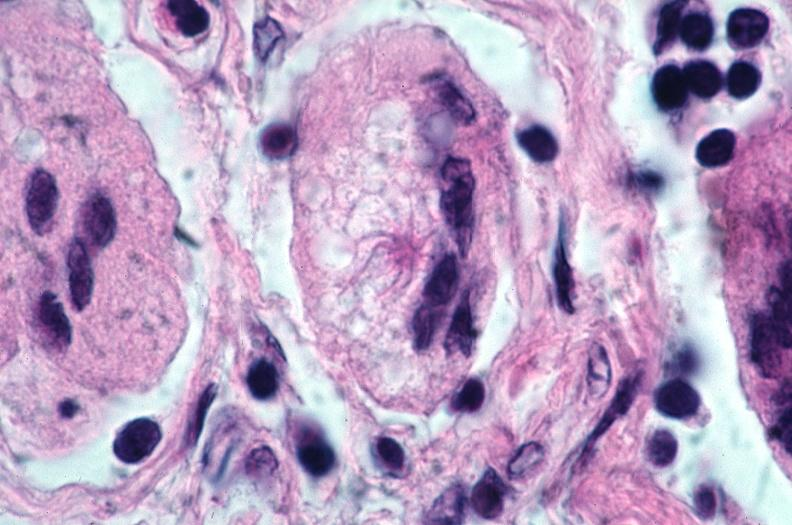how does this image show lung, sarcoidosis, multinucleated giant cells?
Answer the question using a single word or phrase. With asteroid bodies 